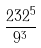Convert formula to latex. <formula><loc_0><loc_0><loc_500><loc_500>\frac { 2 3 2 ^ { 5 } } { 9 ^ { 3 } }</formula> 